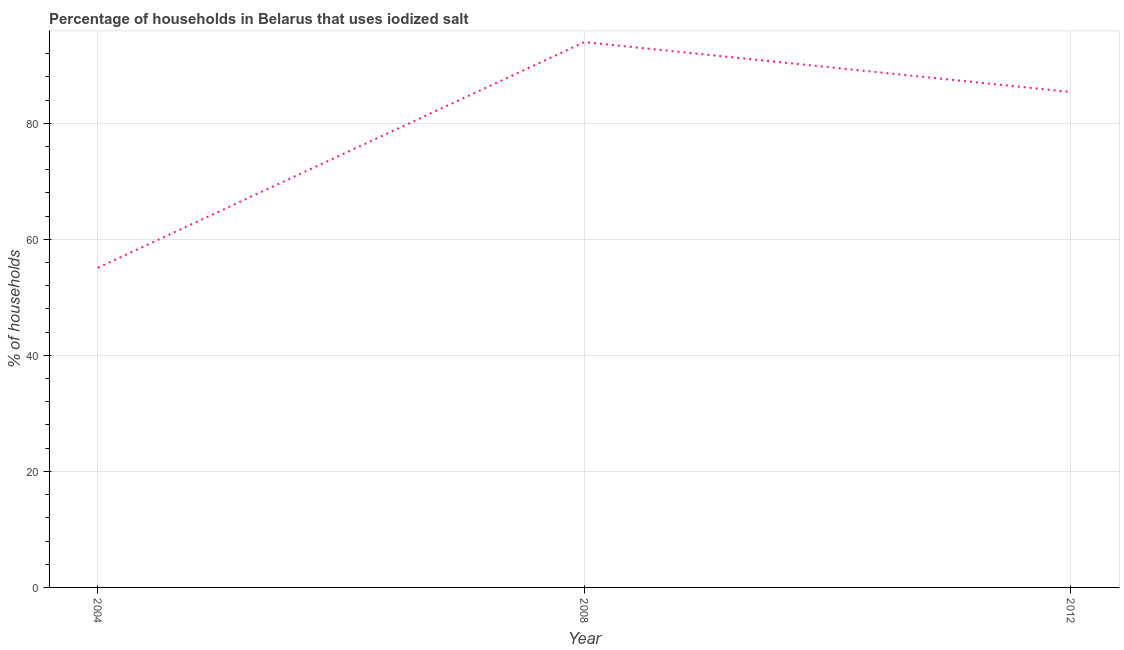What is the percentage of households where iodized salt is consumed in 2012?
Offer a terse response. 85.4. Across all years, what is the maximum percentage of households where iodized salt is consumed?
Offer a very short reply. 94. Across all years, what is the minimum percentage of households where iodized salt is consumed?
Your answer should be compact. 55.1. What is the sum of the percentage of households where iodized salt is consumed?
Provide a succinct answer. 234.5. What is the difference between the percentage of households where iodized salt is consumed in 2008 and 2012?
Provide a short and direct response. 8.6. What is the average percentage of households where iodized salt is consumed per year?
Offer a very short reply. 78.17. What is the median percentage of households where iodized salt is consumed?
Your answer should be compact. 85.4. Do a majority of the years between 2004 and 2012 (inclusive) have percentage of households where iodized salt is consumed greater than 12 %?
Provide a succinct answer. Yes. What is the ratio of the percentage of households where iodized salt is consumed in 2004 to that in 2012?
Make the answer very short. 0.65. Is the percentage of households where iodized salt is consumed in 2008 less than that in 2012?
Offer a very short reply. No. Is the difference between the percentage of households where iodized salt is consumed in 2004 and 2008 greater than the difference between any two years?
Provide a succinct answer. Yes. What is the difference between the highest and the second highest percentage of households where iodized salt is consumed?
Make the answer very short. 8.6. Is the sum of the percentage of households where iodized salt is consumed in 2004 and 2008 greater than the maximum percentage of households where iodized salt is consumed across all years?
Keep it short and to the point. Yes. What is the difference between the highest and the lowest percentage of households where iodized salt is consumed?
Your answer should be compact. 38.9. Does the percentage of households where iodized salt is consumed monotonically increase over the years?
Make the answer very short. No. How many lines are there?
Give a very brief answer. 1. What is the difference between two consecutive major ticks on the Y-axis?
Your response must be concise. 20. Are the values on the major ticks of Y-axis written in scientific E-notation?
Offer a terse response. No. Does the graph contain any zero values?
Your answer should be compact. No. What is the title of the graph?
Keep it short and to the point. Percentage of households in Belarus that uses iodized salt. What is the label or title of the X-axis?
Ensure brevity in your answer.  Year. What is the label or title of the Y-axis?
Provide a succinct answer. % of households. What is the % of households of 2004?
Offer a very short reply. 55.1. What is the % of households of 2008?
Give a very brief answer. 94. What is the % of households of 2012?
Offer a terse response. 85.4. What is the difference between the % of households in 2004 and 2008?
Your response must be concise. -38.9. What is the difference between the % of households in 2004 and 2012?
Provide a succinct answer. -30.3. What is the ratio of the % of households in 2004 to that in 2008?
Provide a short and direct response. 0.59. What is the ratio of the % of households in 2004 to that in 2012?
Provide a short and direct response. 0.65. What is the ratio of the % of households in 2008 to that in 2012?
Your answer should be very brief. 1.1. 